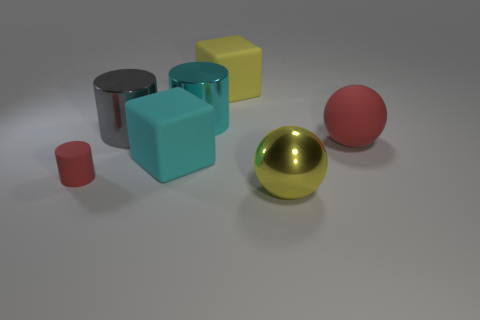The rubber object that is the same color as the rubber cylinder is what shape?
Make the answer very short. Sphere. Are there any other things of the same color as the matte ball?
Offer a very short reply. Yes. The red rubber ball is what size?
Provide a succinct answer. Large. Are there any large things that have the same shape as the small red matte object?
Make the answer very short. Yes. How many things are either big cyan things or objects to the left of the yellow rubber block?
Provide a succinct answer. 4. What is the color of the large metallic cylinder on the left side of the cyan shiny object?
Keep it short and to the point. Gray. Do the red object that is to the left of the cyan metal cylinder and the metal cylinder that is to the left of the large cyan metal cylinder have the same size?
Offer a terse response. No. Is there a brown cube of the same size as the cyan metal thing?
Your answer should be compact. No. What number of red rubber balls are on the right side of the thing right of the big metallic sphere?
Provide a short and direct response. 0. What is the material of the red sphere?
Your response must be concise. Rubber. 